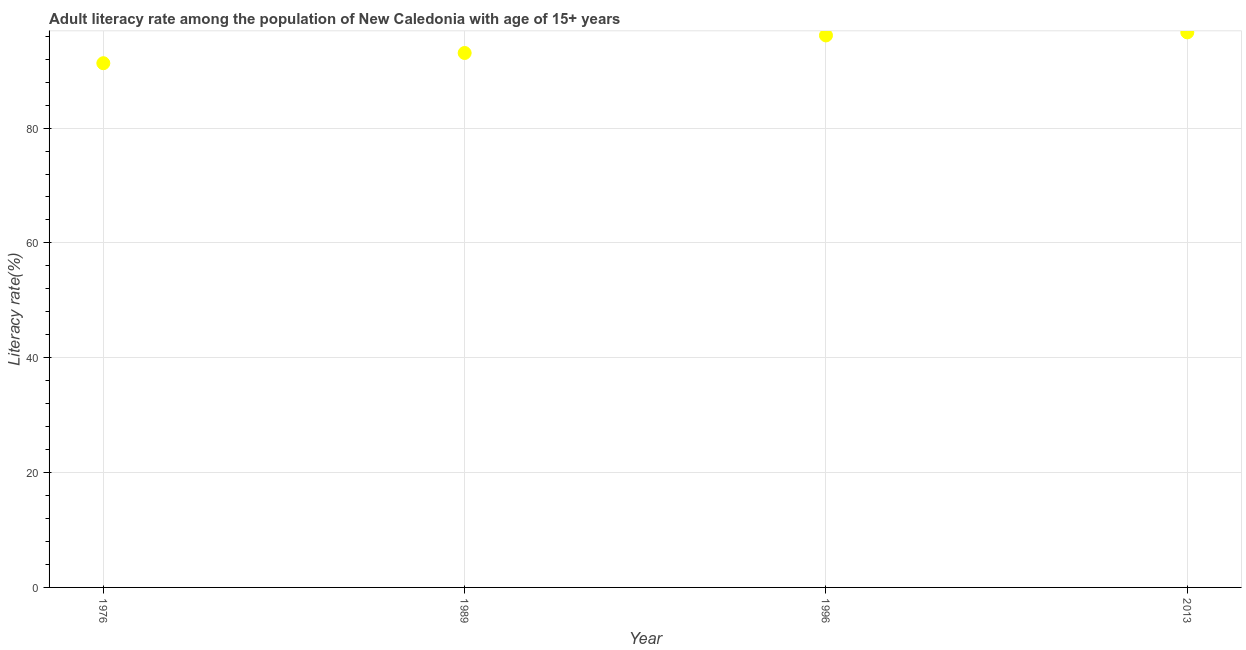What is the adult literacy rate in 1989?
Keep it short and to the point. 93.08. Across all years, what is the maximum adult literacy rate?
Make the answer very short. 96.67. Across all years, what is the minimum adult literacy rate?
Keep it short and to the point. 91.3. In which year was the adult literacy rate minimum?
Your answer should be compact. 1976. What is the sum of the adult literacy rate?
Your answer should be very brief. 377.19. What is the difference between the adult literacy rate in 1976 and 2013?
Offer a terse response. -5.37. What is the average adult literacy rate per year?
Make the answer very short. 94.3. What is the median adult literacy rate?
Give a very brief answer. 94.61. Do a majority of the years between 1976 and 1989 (inclusive) have adult literacy rate greater than 28 %?
Offer a terse response. Yes. What is the ratio of the adult literacy rate in 1976 to that in 2013?
Provide a succinct answer. 0.94. Is the adult literacy rate in 1996 less than that in 2013?
Your response must be concise. Yes. Is the difference between the adult literacy rate in 1989 and 2013 greater than the difference between any two years?
Provide a short and direct response. No. What is the difference between the highest and the second highest adult literacy rate?
Provide a short and direct response. 0.53. What is the difference between the highest and the lowest adult literacy rate?
Your response must be concise. 5.37. How many dotlines are there?
Give a very brief answer. 1. How many years are there in the graph?
Your answer should be compact. 4. What is the difference between two consecutive major ticks on the Y-axis?
Give a very brief answer. 20. Are the values on the major ticks of Y-axis written in scientific E-notation?
Provide a short and direct response. No. Does the graph contain any zero values?
Your response must be concise. No. What is the title of the graph?
Make the answer very short. Adult literacy rate among the population of New Caledonia with age of 15+ years. What is the label or title of the Y-axis?
Ensure brevity in your answer.  Literacy rate(%). What is the Literacy rate(%) in 1976?
Give a very brief answer. 91.3. What is the Literacy rate(%) in 1989?
Offer a terse response. 93.08. What is the Literacy rate(%) in 1996?
Your answer should be compact. 96.14. What is the Literacy rate(%) in 2013?
Offer a very short reply. 96.67. What is the difference between the Literacy rate(%) in 1976 and 1989?
Your response must be concise. -1.78. What is the difference between the Literacy rate(%) in 1976 and 1996?
Give a very brief answer. -4.84. What is the difference between the Literacy rate(%) in 1976 and 2013?
Provide a succinct answer. -5.37. What is the difference between the Literacy rate(%) in 1989 and 1996?
Provide a succinct answer. -3.06. What is the difference between the Literacy rate(%) in 1989 and 2013?
Your answer should be very brief. -3.59. What is the difference between the Literacy rate(%) in 1996 and 2013?
Provide a succinct answer. -0.53. What is the ratio of the Literacy rate(%) in 1976 to that in 1989?
Your response must be concise. 0.98. What is the ratio of the Literacy rate(%) in 1976 to that in 1996?
Your answer should be very brief. 0.95. What is the ratio of the Literacy rate(%) in 1976 to that in 2013?
Your answer should be compact. 0.94. What is the ratio of the Literacy rate(%) in 1989 to that in 1996?
Provide a succinct answer. 0.97. What is the ratio of the Literacy rate(%) in 1989 to that in 2013?
Ensure brevity in your answer.  0.96. What is the ratio of the Literacy rate(%) in 1996 to that in 2013?
Your answer should be compact. 0.99. 